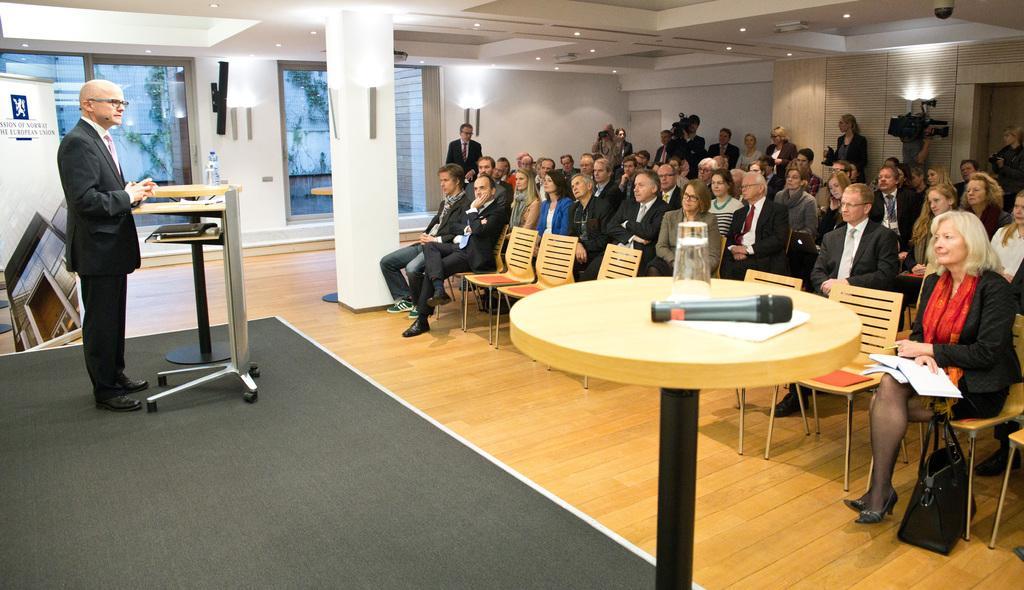Please provide a concise description of this image. This picture is clicked in a conference hall. Here, we see many people sitting on chairs and listening to the man on the opposite side. Man on the left corner wearing black blazer is standing near the podium and explaining something. Behind him, we see a board with some text written on it and on background, we see white wall, pillar and glass windows. In front of picture, we see a table on which microphone, paper and glass are placed. 